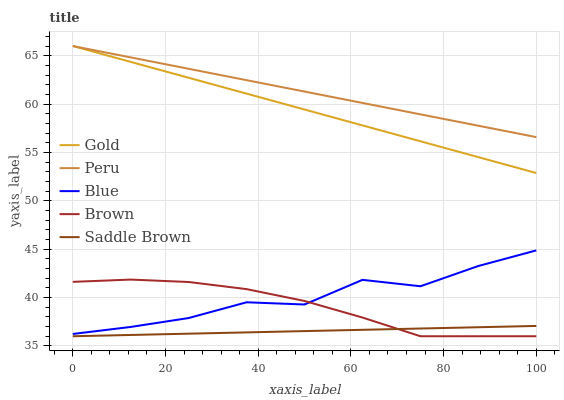Does Saddle Brown have the minimum area under the curve?
Answer yes or no. Yes. Does Peru have the maximum area under the curve?
Answer yes or no. Yes. Does Brown have the minimum area under the curve?
Answer yes or no. No. Does Brown have the maximum area under the curve?
Answer yes or no. No. Is Peru the smoothest?
Answer yes or no. Yes. Is Blue the roughest?
Answer yes or no. Yes. Is Brown the smoothest?
Answer yes or no. No. Is Brown the roughest?
Answer yes or no. No. Does Brown have the lowest value?
Answer yes or no. Yes. Does Peru have the lowest value?
Answer yes or no. No. Does Gold have the highest value?
Answer yes or no. Yes. Does Brown have the highest value?
Answer yes or no. No. Is Blue less than Peru?
Answer yes or no. Yes. Is Blue greater than Saddle Brown?
Answer yes or no. Yes. Does Peru intersect Gold?
Answer yes or no. Yes. Is Peru less than Gold?
Answer yes or no. No. Is Peru greater than Gold?
Answer yes or no. No. Does Blue intersect Peru?
Answer yes or no. No. 